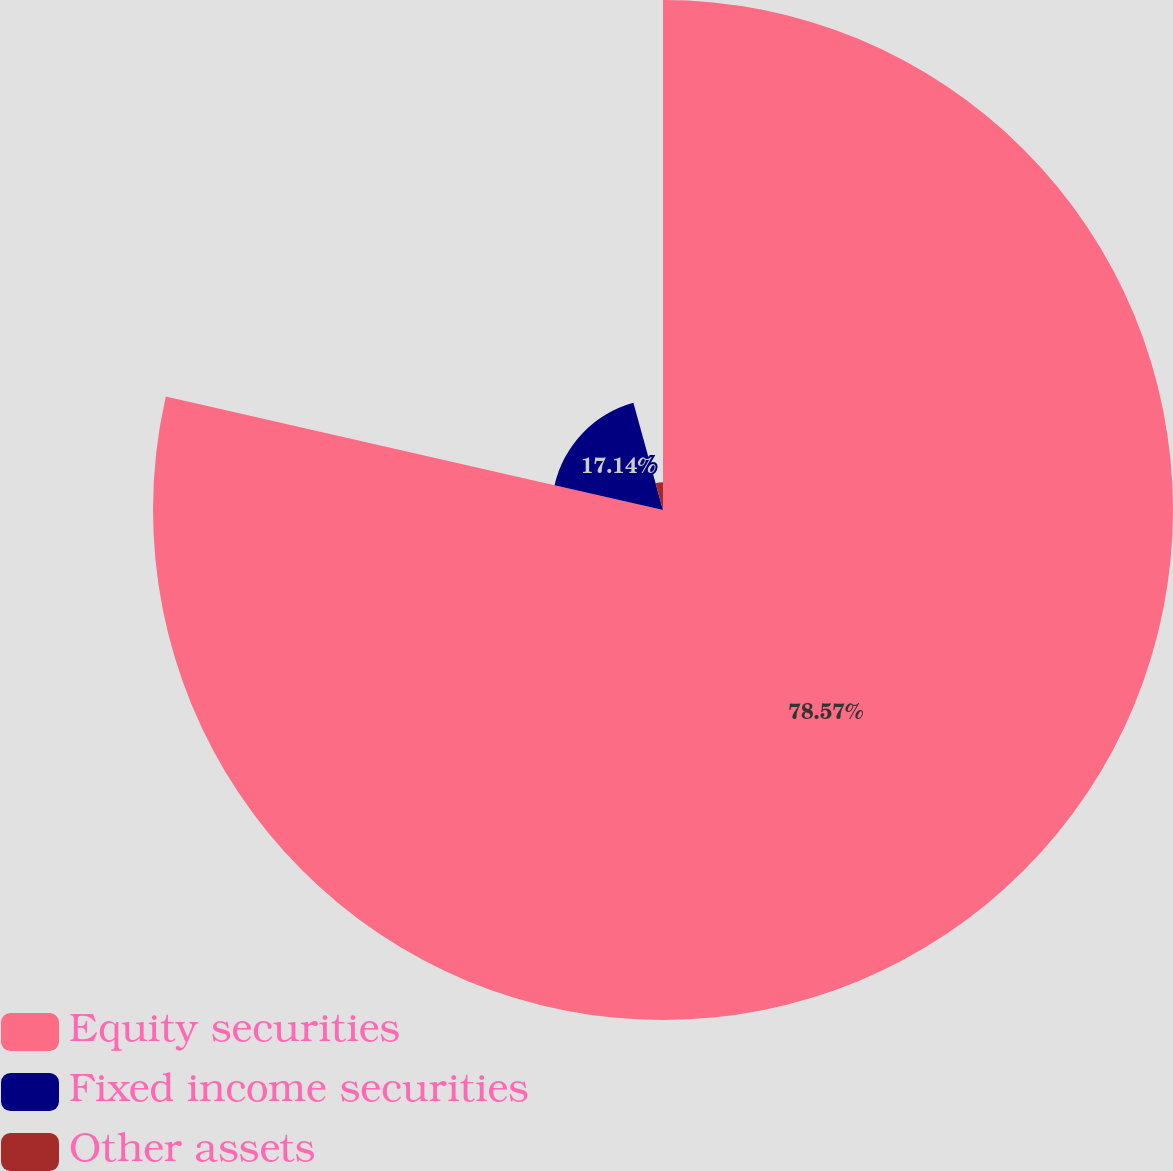Convert chart to OTSL. <chart><loc_0><loc_0><loc_500><loc_500><pie_chart><fcel>Equity securities<fcel>Fixed income securities<fcel>Other assets<nl><fcel>78.57%<fcel>17.14%<fcel>4.29%<nl></chart> 